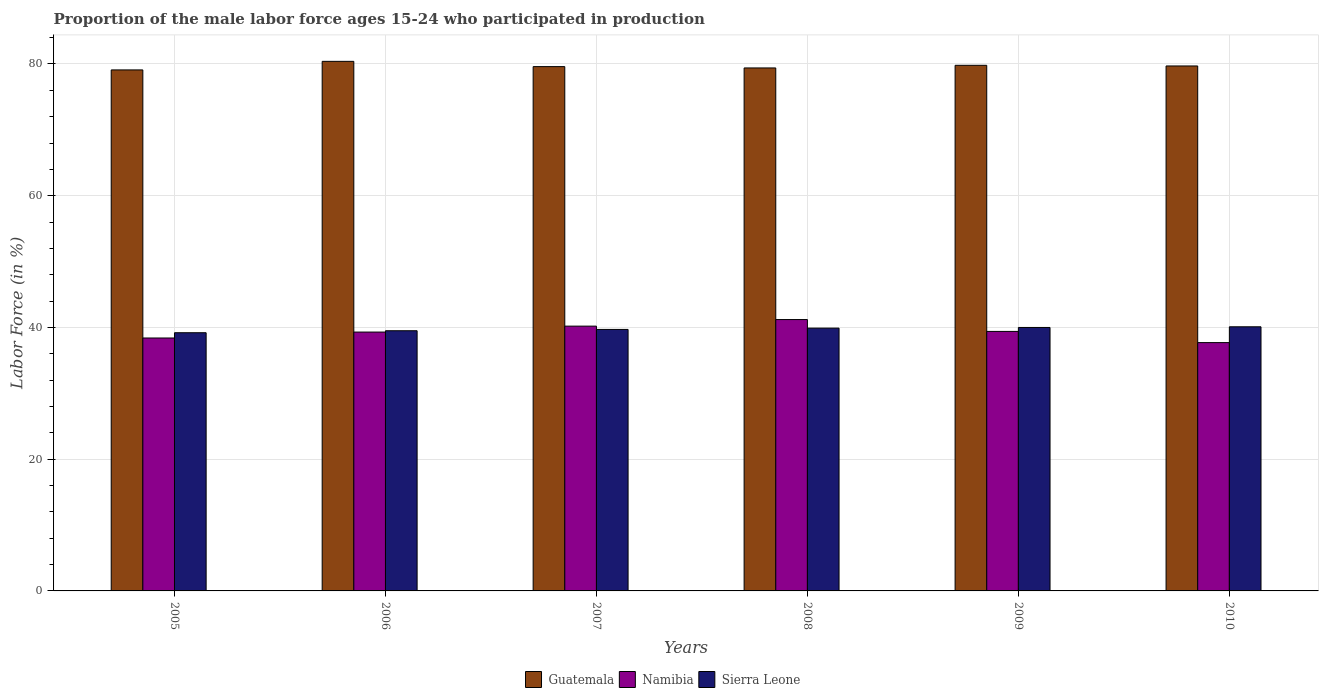How many different coloured bars are there?
Provide a succinct answer. 3. Are the number of bars on each tick of the X-axis equal?
Your answer should be compact. Yes. How many bars are there on the 1st tick from the right?
Your answer should be compact. 3. In how many cases, is the number of bars for a given year not equal to the number of legend labels?
Give a very brief answer. 0. What is the proportion of the male labor force who participated in production in Guatemala in 2007?
Offer a very short reply. 79.6. Across all years, what is the maximum proportion of the male labor force who participated in production in Namibia?
Make the answer very short. 41.2. Across all years, what is the minimum proportion of the male labor force who participated in production in Sierra Leone?
Ensure brevity in your answer.  39.2. In which year was the proportion of the male labor force who participated in production in Guatemala minimum?
Ensure brevity in your answer.  2005. What is the total proportion of the male labor force who participated in production in Namibia in the graph?
Your response must be concise. 236.2. What is the difference between the proportion of the male labor force who participated in production in Sierra Leone in 2008 and the proportion of the male labor force who participated in production in Namibia in 2010?
Ensure brevity in your answer.  2.2. What is the average proportion of the male labor force who participated in production in Guatemala per year?
Offer a terse response. 79.67. In the year 2010, what is the difference between the proportion of the male labor force who participated in production in Guatemala and proportion of the male labor force who participated in production in Sierra Leone?
Provide a succinct answer. 39.6. What is the ratio of the proportion of the male labor force who participated in production in Sierra Leone in 2008 to that in 2010?
Make the answer very short. 1. Is the proportion of the male labor force who participated in production in Guatemala in 2005 less than that in 2008?
Your answer should be compact. Yes. Is the difference between the proportion of the male labor force who participated in production in Guatemala in 2007 and 2008 greater than the difference between the proportion of the male labor force who participated in production in Sierra Leone in 2007 and 2008?
Provide a succinct answer. Yes. What is the difference between the highest and the lowest proportion of the male labor force who participated in production in Sierra Leone?
Offer a terse response. 0.9. What does the 2nd bar from the left in 2008 represents?
Make the answer very short. Namibia. What does the 2nd bar from the right in 2008 represents?
Your answer should be compact. Namibia. Is it the case that in every year, the sum of the proportion of the male labor force who participated in production in Namibia and proportion of the male labor force who participated in production in Guatemala is greater than the proportion of the male labor force who participated in production in Sierra Leone?
Provide a succinct answer. Yes. How many bars are there?
Give a very brief answer. 18. Are all the bars in the graph horizontal?
Provide a succinct answer. No. Does the graph contain any zero values?
Offer a very short reply. No. Does the graph contain grids?
Give a very brief answer. Yes. Where does the legend appear in the graph?
Your answer should be very brief. Bottom center. What is the title of the graph?
Your answer should be compact. Proportion of the male labor force ages 15-24 who participated in production. What is the Labor Force (in %) in Guatemala in 2005?
Ensure brevity in your answer.  79.1. What is the Labor Force (in %) in Namibia in 2005?
Ensure brevity in your answer.  38.4. What is the Labor Force (in %) of Sierra Leone in 2005?
Your answer should be compact. 39.2. What is the Labor Force (in %) of Guatemala in 2006?
Keep it short and to the point. 80.4. What is the Labor Force (in %) in Namibia in 2006?
Provide a succinct answer. 39.3. What is the Labor Force (in %) of Sierra Leone in 2006?
Give a very brief answer. 39.5. What is the Labor Force (in %) of Guatemala in 2007?
Keep it short and to the point. 79.6. What is the Labor Force (in %) in Namibia in 2007?
Your answer should be very brief. 40.2. What is the Labor Force (in %) of Sierra Leone in 2007?
Your answer should be very brief. 39.7. What is the Labor Force (in %) of Guatemala in 2008?
Offer a terse response. 79.4. What is the Labor Force (in %) in Namibia in 2008?
Offer a very short reply. 41.2. What is the Labor Force (in %) of Sierra Leone in 2008?
Keep it short and to the point. 39.9. What is the Labor Force (in %) of Guatemala in 2009?
Your answer should be very brief. 79.8. What is the Labor Force (in %) of Namibia in 2009?
Your response must be concise. 39.4. What is the Labor Force (in %) of Guatemala in 2010?
Offer a very short reply. 79.7. What is the Labor Force (in %) of Namibia in 2010?
Your response must be concise. 37.7. What is the Labor Force (in %) of Sierra Leone in 2010?
Give a very brief answer. 40.1. Across all years, what is the maximum Labor Force (in %) in Guatemala?
Provide a succinct answer. 80.4. Across all years, what is the maximum Labor Force (in %) of Namibia?
Make the answer very short. 41.2. Across all years, what is the maximum Labor Force (in %) of Sierra Leone?
Your response must be concise. 40.1. Across all years, what is the minimum Labor Force (in %) of Guatemala?
Keep it short and to the point. 79.1. Across all years, what is the minimum Labor Force (in %) in Namibia?
Make the answer very short. 37.7. Across all years, what is the minimum Labor Force (in %) in Sierra Leone?
Offer a very short reply. 39.2. What is the total Labor Force (in %) of Guatemala in the graph?
Make the answer very short. 478. What is the total Labor Force (in %) in Namibia in the graph?
Give a very brief answer. 236.2. What is the total Labor Force (in %) in Sierra Leone in the graph?
Provide a short and direct response. 238.4. What is the difference between the Labor Force (in %) in Namibia in 2005 and that in 2006?
Give a very brief answer. -0.9. What is the difference between the Labor Force (in %) in Guatemala in 2005 and that in 2007?
Provide a succinct answer. -0.5. What is the difference between the Labor Force (in %) in Namibia in 2005 and that in 2007?
Keep it short and to the point. -1.8. What is the difference between the Labor Force (in %) of Sierra Leone in 2005 and that in 2007?
Offer a very short reply. -0.5. What is the difference between the Labor Force (in %) in Sierra Leone in 2005 and that in 2008?
Offer a very short reply. -0.7. What is the difference between the Labor Force (in %) of Guatemala in 2005 and that in 2009?
Ensure brevity in your answer.  -0.7. What is the difference between the Labor Force (in %) in Sierra Leone in 2005 and that in 2009?
Offer a very short reply. -0.8. What is the difference between the Labor Force (in %) of Guatemala in 2005 and that in 2010?
Your response must be concise. -0.6. What is the difference between the Labor Force (in %) in Sierra Leone in 2005 and that in 2010?
Offer a very short reply. -0.9. What is the difference between the Labor Force (in %) in Guatemala in 2006 and that in 2007?
Provide a succinct answer. 0.8. What is the difference between the Labor Force (in %) in Sierra Leone in 2006 and that in 2007?
Offer a terse response. -0.2. What is the difference between the Labor Force (in %) in Namibia in 2006 and that in 2009?
Your answer should be very brief. -0.1. What is the difference between the Labor Force (in %) in Namibia in 2007 and that in 2008?
Provide a succinct answer. -1. What is the difference between the Labor Force (in %) of Sierra Leone in 2007 and that in 2008?
Offer a very short reply. -0.2. What is the difference between the Labor Force (in %) of Guatemala in 2007 and that in 2009?
Your answer should be very brief. -0.2. What is the difference between the Labor Force (in %) in Namibia in 2007 and that in 2009?
Provide a short and direct response. 0.8. What is the difference between the Labor Force (in %) in Sierra Leone in 2007 and that in 2010?
Provide a short and direct response. -0.4. What is the difference between the Labor Force (in %) of Guatemala in 2008 and that in 2009?
Provide a short and direct response. -0.4. What is the difference between the Labor Force (in %) in Namibia in 2008 and that in 2009?
Offer a very short reply. 1.8. What is the difference between the Labor Force (in %) in Guatemala in 2008 and that in 2010?
Ensure brevity in your answer.  -0.3. What is the difference between the Labor Force (in %) in Namibia in 2008 and that in 2010?
Give a very brief answer. 3.5. What is the difference between the Labor Force (in %) of Sierra Leone in 2008 and that in 2010?
Offer a very short reply. -0.2. What is the difference between the Labor Force (in %) of Guatemala in 2009 and that in 2010?
Provide a succinct answer. 0.1. What is the difference between the Labor Force (in %) of Sierra Leone in 2009 and that in 2010?
Offer a very short reply. -0.1. What is the difference between the Labor Force (in %) of Guatemala in 2005 and the Labor Force (in %) of Namibia in 2006?
Your response must be concise. 39.8. What is the difference between the Labor Force (in %) in Guatemala in 2005 and the Labor Force (in %) in Sierra Leone in 2006?
Provide a short and direct response. 39.6. What is the difference between the Labor Force (in %) of Namibia in 2005 and the Labor Force (in %) of Sierra Leone in 2006?
Give a very brief answer. -1.1. What is the difference between the Labor Force (in %) of Guatemala in 2005 and the Labor Force (in %) of Namibia in 2007?
Offer a terse response. 38.9. What is the difference between the Labor Force (in %) of Guatemala in 2005 and the Labor Force (in %) of Sierra Leone in 2007?
Your answer should be compact. 39.4. What is the difference between the Labor Force (in %) of Guatemala in 2005 and the Labor Force (in %) of Namibia in 2008?
Your answer should be very brief. 37.9. What is the difference between the Labor Force (in %) of Guatemala in 2005 and the Labor Force (in %) of Sierra Leone in 2008?
Your response must be concise. 39.2. What is the difference between the Labor Force (in %) in Guatemala in 2005 and the Labor Force (in %) in Namibia in 2009?
Your answer should be very brief. 39.7. What is the difference between the Labor Force (in %) of Guatemala in 2005 and the Labor Force (in %) of Sierra Leone in 2009?
Your answer should be compact. 39.1. What is the difference between the Labor Force (in %) in Namibia in 2005 and the Labor Force (in %) in Sierra Leone in 2009?
Offer a terse response. -1.6. What is the difference between the Labor Force (in %) in Guatemala in 2005 and the Labor Force (in %) in Namibia in 2010?
Keep it short and to the point. 41.4. What is the difference between the Labor Force (in %) in Guatemala in 2005 and the Labor Force (in %) in Sierra Leone in 2010?
Give a very brief answer. 39. What is the difference between the Labor Force (in %) in Namibia in 2005 and the Labor Force (in %) in Sierra Leone in 2010?
Your answer should be very brief. -1.7. What is the difference between the Labor Force (in %) of Guatemala in 2006 and the Labor Force (in %) of Namibia in 2007?
Ensure brevity in your answer.  40.2. What is the difference between the Labor Force (in %) of Guatemala in 2006 and the Labor Force (in %) of Sierra Leone in 2007?
Offer a terse response. 40.7. What is the difference between the Labor Force (in %) in Namibia in 2006 and the Labor Force (in %) in Sierra Leone in 2007?
Your answer should be very brief. -0.4. What is the difference between the Labor Force (in %) in Guatemala in 2006 and the Labor Force (in %) in Namibia in 2008?
Provide a short and direct response. 39.2. What is the difference between the Labor Force (in %) of Guatemala in 2006 and the Labor Force (in %) of Sierra Leone in 2008?
Give a very brief answer. 40.5. What is the difference between the Labor Force (in %) of Namibia in 2006 and the Labor Force (in %) of Sierra Leone in 2008?
Ensure brevity in your answer.  -0.6. What is the difference between the Labor Force (in %) in Guatemala in 2006 and the Labor Force (in %) in Namibia in 2009?
Ensure brevity in your answer.  41. What is the difference between the Labor Force (in %) in Guatemala in 2006 and the Labor Force (in %) in Sierra Leone in 2009?
Provide a short and direct response. 40.4. What is the difference between the Labor Force (in %) in Namibia in 2006 and the Labor Force (in %) in Sierra Leone in 2009?
Keep it short and to the point. -0.7. What is the difference between the Labor Force (in %) in Guatemala in 2006 and the Labor Force (in %) in Namibia in 2010?
Provide a short and direct response. 42.7. What is the difference between the Labor Force (in %) in Guatemala in 2006 and the Labor Force (in %) in Sierra Leone in 2010?
Your answer should be very brief. 40.3. What is the difference between the Labor Force (in %) in Guatemala in 2007 and the Labor Force (in %) in Namibia in 2008?
Keep it short and to the point. 38.4. What is the difference between the Labor Force (in %) in Guatemala in 2007 and the Labor Force (in %) in Sierra Leone in 2008?
Provide a succinct answer. 39.7. What is the difference between the Labor Force (in %) in Namibia in 2007 and the Labor Force (in %) in Sierra Leone in 2008?
Provide a succinct answer. 0.3. What is the difference between the Labor Force (in %) in Guatemala in 2007 and the Labor Force (in %) in Namibia in 2009?
Your response must be concise. 40.2. What is the difference between the Labor Force (in %) in Guatemala in 2007 and the Labor Force (in %) in Sierra Leone in 2009?
Ensure brevity in your answer.  39.6. What is the difference between the Labor Force (in %) of Namibia in 2007 and the Labor Force (in %) of Sierra Leone in 2009?
Your answer should be very brief. 0.2. What is the difference between the Labor Force (in %) of Guatemala in 2007 and the Labor Force (in %) of Namibia in 2010?
Keep it short and to the point. 41.9. What is the difference between the Labor Force (in %) in Guatemala in 2007 and the Labor Force (in %) in Sierra Leone in 2010?
Provide a short and direct response. 39.5. What is the difference between the Labor Force (in %) in Namibia in 2007 and the Labor Force (in %) in Sierra Leone in 2010?
Provide a succinct answer. 0.1. What is the difference between the Labor Force (in %) of Guatemala in 2008 and the Labor Force (in %) of Namibia in 2009?
Offer a very short reply. 40. What is the difference between the Labor Force (in %) in Guatemala in 2008 and the Labor Force (in %) in Sierra Leone in 2009?
Your answer should be very brief. 39.4. What is the difference between the Labor Force (in %) in Namibia in 2008 and the Labor Force (in %) in Sierra Leone in 2009?
Give a very brief answer. 1.2. What is the difference between the Labor Force (in %) of Guatemala in 2008 and the Labor Force (in %) of Namibia in 2010?
Your answer should be very brief. 41.7. What is the difference between the Labor Force (in %) in Guatemala in 2008 and the Labor Force (in %) in Sierra Leone in 2010?
Provide a succinct answer. 39.3. What is the difference between the Labor Force (in %) of Namibia in 2008 and the Labor Force (in %) of Sierra Leone in 2010?
Your answer should be very brief. 1.1. What is the difference between the Labor Force (in %) of Guatemala in 2009 and the Labor Force (in %) of Namibia in 2010?
Make the answer very short. 42.1. What is the difference between the Labor Force (in %) in Guatemala in 2009 and the Labor Force (in %) in Sierra Leone in 2010?
Keep it short and to the point. 39.7. What is the average Labor Force (in %) in Guatemala per year?
Provide a short and direct response. 79.67. What is the average Labor Force (in %) in Namibia per year?
Make the answer very short. 39.37. What is the average Labor Force (in %) in Sierra Leone per year?
Provide a short and direct response. 39.73. In the year 2005, what is the difference between the Labor Force (in %) of Guatemala and Labor Force (in %) of Namibia?
Offer a terse response. 40.7. In the year 2005, what is the difference between the Labor Force (in %) of Guatemala and Labor Force (in %) of Sierra Leone?
Your answer should be very brief. 39.9. In the year 2005, what is the difference between the Labor Force (in %) of Namibia and Labor Force (in %) of Sierra Leone?
Ensure brevity in your answer.  -0.8. In the year 2006, what is the difference between the Labor Force (in %) in Guatemala and Labor Force (in %) in Namibia?
Your answer should be compact. 41.1. In the year 2006, what is the difference between the Labor Force (in %) in Guatemala and Labor Force (in %) in Sierra Leone?
Ensure brevity in your answer.  40.9. In the year 2006, what is the difference between the Labor Force (in %) in Namibia and Labor Force (in %) in Sierra Leone?
Ensure brevity in your answer.  -0.2. In the year 2007, what is the difference between the Labor Force (in %) in Guatemala and Labor Force (in %) in Namibia?
Offer a very short reply. 39.4. In the year 2007, what is the difference between the Labor Force (in %) in Guatemala and Labor Force (in %) in Sierra Leone?
Your answer should be compact. 39.9. In the year 2007, what is the difference between the Labor Force (in %) of Namibia and Labor Force (in %) of Sierra Leone?
Ensure brevity in your answer.  0.5. In the year 2008, what is the difference between the Labor Force (in %) in Guatemala and Labor Force (in %) in Namibia?
Provide a succinct answer. 38.2. In the year 2008, what is the difference between the Labor Force (in %) of Guatemala and Labor Force (in %) of Sierra Leone?
Provide a succinct answer. 39.5. In the year 2008, what is the difference between the Labor Force (in %) of Namibia and Labor Force (in %) of Sierra Leone?
Your response must be concise. 1.3. In the year 2009, what is the difference between the Labor Force (in %) of Guatemala and Labor Force (in %) of Namibia?
Provide a short and direct response. 40.4. In the year 2009, what is the difference between the Labor Force (in %) of Guatemala and Labor Force (in %) of Sierra Leone?
Make the answer very short. 39.8. In the year 2009, what is the difference between the Labor Force (in %) in Namibia and Labor Force (in %) in Sierra Leone?
Your response must be concise. -0.6. In the year 2010, what is the difference between the Labor Force (in %) of Guatemala and Labor Force (in %) of Namibia?
Your response must be concise. 42. In the year 2010, what is the difference between the Labor Force (in %) of Guatemala and Labor Force (in %) of Sierra Leone?
Your answer should be compact. 39.6. What is the ratio of the Labor Force (in %) of Guatemala in 2005 to that in 2006?
Give a very brief answer. 0.98. What is the ratio of the Labor Force (in %) in Namibia in 2005 to that in 2006?
Keep it short and to the point. 0.98. What is the ratio of the Labor Force (in %) in Guatemala in 2005 to that in 2007?
Provide a short and direct response. 0.99. What is the ratio of the Labor Force (in %) of Namibia in 2005 to that in 2007?
Offer a terse response. 0.96. What is the ratio of the Labor Force (in %) of Sierra Leone in 2005 to that in 2007?
Your response must be concise. 0.99. What is the ratio of the Labor Force (in %) of Namibia in 2005 to that in 2008?
Ensure brevity in your answer.  0.93. What is the ratio of the Labor Force (in %) of Sierra Leone in 2005 to that in 2008?
Your answer should be compact. 0.98. What is the ratio of the Labor Force (in %) of Guatemala in 2005 to that in 2009?
Your answer should be compact. 0.99. What is the ratio of the Labor Force (in %) in Namibia in 2005 to that in 2009?
Offer a terse response. 0.97. What is the ratio of the Labor Force (in %) in Guatemala in 2005 to that in 2010?
Make the answer very short. 0.99. What is the ratio of the Labor Force (in %) in Namibia in 2005 to that in 2010?
Ensure brevity in your answer.  1.02. What is the ratio of the Labor Force (in %) of Sierra Leone in 2005 to that in 2010?
Make the answer very short. 0.98. What is the ratio of the Labor Force (in %) in Namibia in 2006 to that in 2007?
Offer a terse response. 0.98. What is the ratio of the Labor Force (in %) of Sierra Leone in 2006 to that in 2007?
Give a very brief answer. 0.99. What is the ratio of the Labor Force (in %) in Guatemala in 2006 to that in 2008?
Keep it short and to the point. 1.01. What is the ratio of the Labor Force (in %) of Namibia in 2006 to that in 2008?
Give a very brief answer. 0.95. What is the ratio of the Labor Force (in %) of Guatemala in 2006 to that in 2009?
Your response must be concise. 1.01. What is the ratio of the Labor Force (in %) of Sierra Leone in 2006 to that in 2009?
Your response must be concise. 0.99. What is the ratio of the Labor Force (in %) of Guatemala in 2006 to that in 2010?
Make the answer very short. 1.01. What is the ratio of the Labor Force (in %) in Namibia in 2006 to that in 2010?
Offer a very short reply. 1.04. What is the ratio of the Labor Force (in %) of Sierra Leone in 2006 to that in 2010?
Your answer should be compact. 0.98. What is the ratio of the Labor Force (in %) in Namibia in 2007 to that in 2008?
Your answer should be very brief. 0.98. What is the ratio of the Labor Force (in %) of Guatemala in 2007 to that in 2009?
Provide a short and direct response. 1. What is the ratio of the Labor Force (in %) in Namibia in 2007 to that in 2009?
Offer a terse response. 1.02. What is the ratio of the Labor Force (in %) in Sierra Leone in 2007 to that in 2009?
Your answer should be very brief. 0.99. What is the ratio of the Labor Force (in %) in Namibia in 2007 to that in 2010?
Provide a succinct answer. 1.07. What is the ratio of the Labor Force (in %) in Namibia in 2008 to that in 2009?
Keep it short and to the point. 1.05. What is the ratio of the Labor Force (in %) of Sierra Leone in 2008 to that in 2009?
Ensure brevity in your answer.  1. What is the ratio of the Labor Force (in %) of Guatemala in 2008 to that in 2010?
Provide a short and direct response. 1. What is the ratio of the Labor Force (in %) of Namibia in 2008 to that in 2010?
Keep it short and to the point. 1.09. What is the ratio of the Labor Force (in %) in Guatemala in 2009 to that in 2010?
Your response must be concise. 1. What is the ratio of the Labor Force (in %) in Namibia in 2009 to that in 2010?
Make the answer very short. 1.05. What is the difference between the highest and the second highest Labor Force (in %) in Guatemala?
Keep it short and to the point. 0.6. What is the difference between the highest and the lowest Labor Force (in %) of Sierra Leone?
Provide a short and direct response. 0.9. 